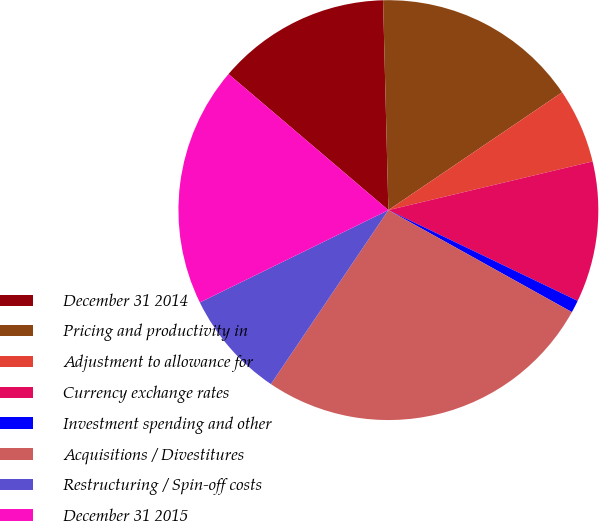<chart> <loc_0><loc_0><loc_500><loc_500><pie_chart><fcel>December 31 2014<fcel>Pricing and productivity in<fcel>Adjustment to allowance for<fcel>Currency exchange rates<fcel>Investment spending and other<fcel>Acquisitions / Divestitures<fcel>Restructuring / Spin-off costs<fcel>December 31 2015<nl><fcel>13.38%<fcel>15.92%<fcel>5.76%<fcel>10.84%<fcel>0.96%<fcel>26.38%<fcel>8.3%<fcel>18.47%<nl></chart> 